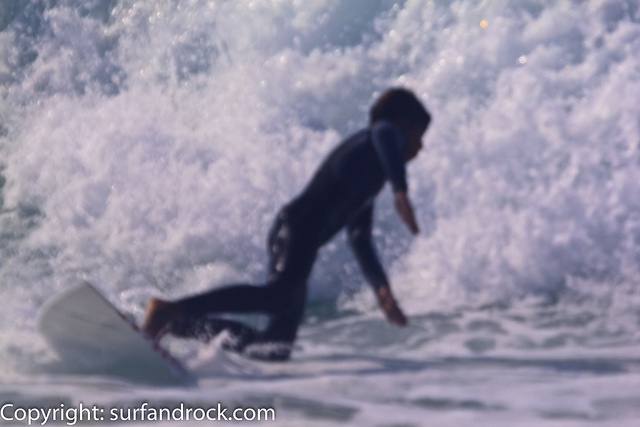Describe the objects in this image and their specific colors. I can see people in gray, black, and darkgray tones and surfboard in gray tones in this image. 